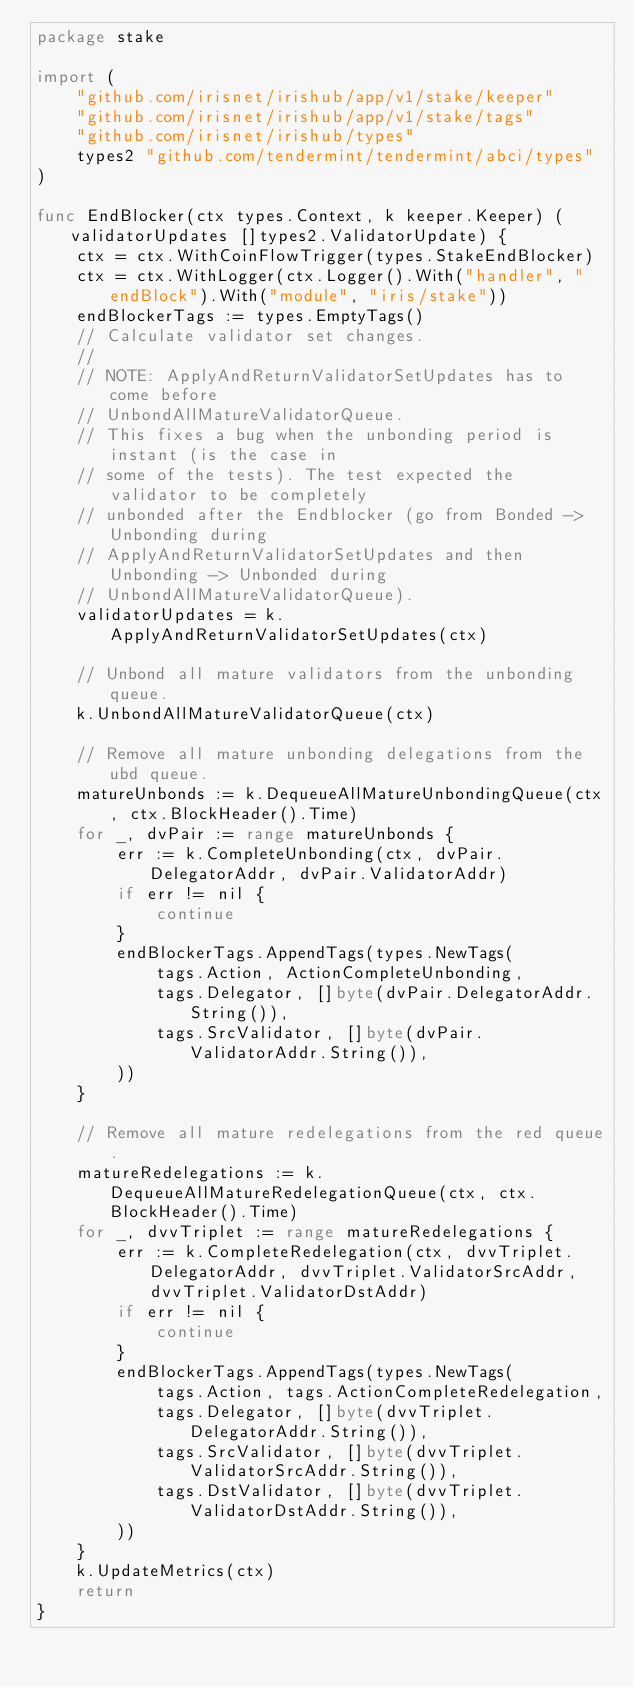Convert code to text. <code><loc_0><loc_0><loc_500><loc_500><_Go_>package stake

import (
	"github.com/irisnet/irishub/app/v1/stake/keeper"
	"github.com/irisnet/irishub/app/v1/stake/tags"
	"github.com/irisnet/irishub/types"
	types2 "github.com/tendermint/tendermint/abci/types"
)

func EndBlocker(ctx types.Context, k keeper.Keeper) (validatorUpdates []types2.ValidatorUpdate) {
	ctx = ctx.WithCoinFlowTrigger(types.StakeEndBlocker)
	ctx = ctx.WithLogger(ctx.Logger().With("handler", "endBlock").With("module", "iris/stake"))
	endBlockerTags := types.EmptyTags()
	// Calculate validator set changes.
	//
	// NOTE: ApplyAndReturnValidatorSetUpdates has to come before
	// UnbondAllMatureValidatorQueue.
	// This fixes a bug when the unbonding period is instant (is the case in
	// some of the tests). The test expected the validator to be completely
	// unbonded after the Endblocker (go from Bonded -> Unbonding during
	// ApplyAndReturnValidatorSetUpdates and then Unbonding -> Unbonded during
	// UnbondAllMatureValidatorQueue).
	validatorUpdates = k.ApplyAndReturnValidatorSetUpdates(ctx)

	// Unbond all mature validators from the unbonding queue.
	k.UnbondAllMatureValidatorQueue(ctx)

	// Remove all mature unbonding delegations from the ubd queue.
	matureUnbonds := k.DequeueAllMatureUnbondingQueue(ctx, ctx.BlockHeader().Time)
	for _, dvPair := range matureUnbonds {
		err := k.CompleteUnbonding(ctx, dvPair.DelegatorAddr, dvPair.ValidatorAddr)
		if err != nil {
			continue
		}
		endBlockerTags.AppendTags(types.NewTags(
			tags.Action, ActionCompleteUnbonding,
			tags.Delegator, []byte(dvPair.DelegatorAddr.String()),
			tags.SrcValidator, []byte(dvPair.ValidatorAddr.String()),
		))
	}

	// Remove all mature redelegations from the red queue.
	matureRedelegations := k.DequeueAllMatureRedelegationQueue(ctx, ctx.BlockHeader().Time)
	for _, dvvTriplet := range matureRedelegations {
		err := k.CompleteRedelegation(ctx, dvvTriplet.DelegatorAddr, dvvTriplet.ValidatorSrcAddr, dvvTriplet.ValidatorDstAddr)
		if err != nil {
			continue
		}
		endBlockerTags.AppendTags(types.NewTags(
			tags.Action, tags.ActionCompleteRedelegation,
			tags.Delegator, []byte(dvvTriplet.DelegatorAddr.String()),
			tags.SrcValidator, []byte(dvvTriplet.ValidatorSrcAddr.String()),
			tags.DstValidator, []byte(dvvTriplet.ValidatorDstAddr.String()),
		))
	}
	k.UpdateMetrics(ctx)
	return
}
</code> 